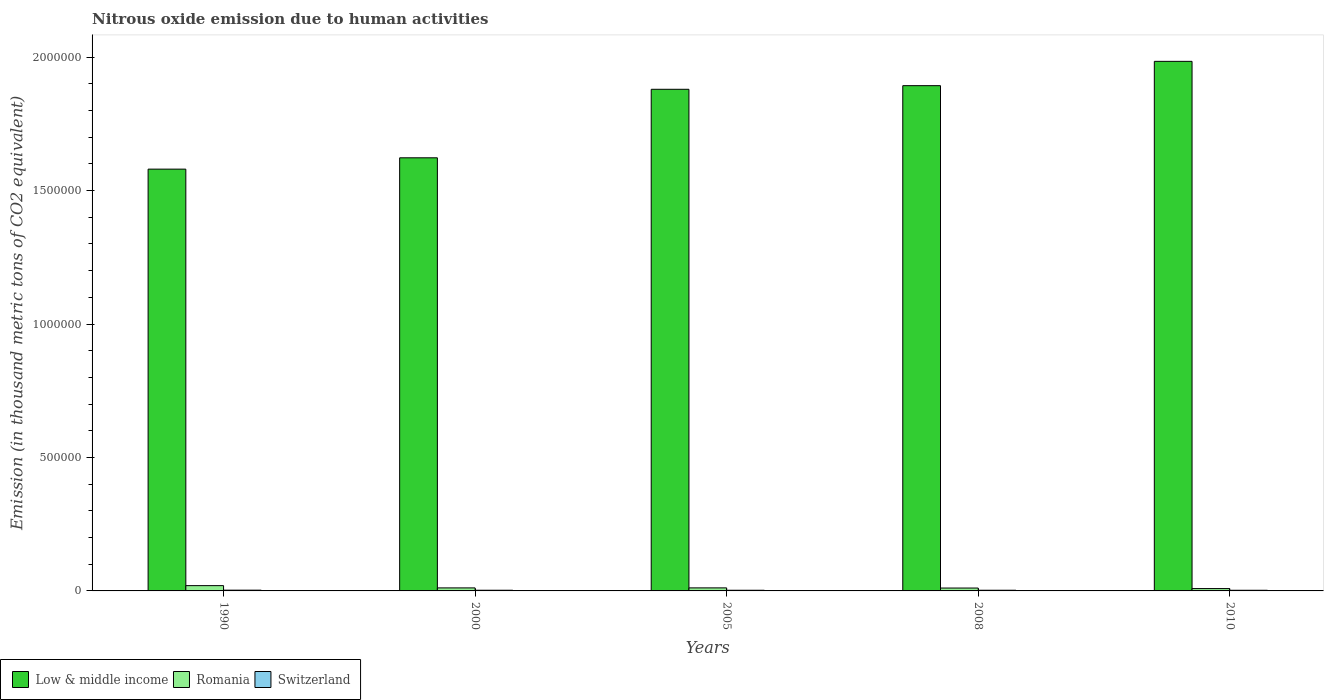How many different coloured bars are there?
Keep it short and to the point. 3. What is the label of the 4th group of bars from the left?
Offer a terse response. 2008. In how many cases, is the number of bars for a given year not equal to the number of legend labels?
Your response must be concise. 0. What is the amount of nitrous oxide emitted in Low & middle income in 2005?
Provide a short and direct response. 1.88e+06. Across all years, what is the maximum amount of nitrous oxide emitted in Romania?
Provide a succinct answer. 1.98e+04. Across all years, what is the minimum amount of nitrous oxide emitted in Switzerland?
Your answer should be compact. 2441.9. What is the total amount of nitrous oxide emitted in Low & middle income in the graph?
Ensure brevity in your answer.  8.96e+06. What is the difference between the amount of nitrous oxide emitted in Low & middle income in 2005 and that in 2010?
Offer a terse response. -1.05e+05. What is the difference between the amount of nitrous oxide emitted in Switzerland in 2000 and the amount of nitrous oxide emitted in Low & middle income in 2010?
Your answer should be compact. -1.98e+06. What is the average amount of nitrous oxide emitted in Switzerland per year?
Provide a short and direct response. 2568.88. In the year 2010, what is the difference between the amount of nitrous oxide emitted in Low & middle income and amount of nitrous oxide emitted in Switzerland?
Give a very brief answer. 1.98e+06. What is the ratio of the amount of nitrous oxide emitted in Low & middle income in 1990 to that in 2005?
Your response must be concise. 0.84. Is the amount of nitrous oxide emitted in Romania in 2000 less than that in 2008?
Make the answer very short. No. What is the difference between the highest and the second highest amount of nitrous oxide emitted in Switzerland?
Your answer should be very brief. 294.5. What is the difference between the highest and the lowest amount of nitrous oxide emitted in Low & middle income?
Keep it short and to the point. 4.04e+05. In how many years, is the amount of nitrous oxide emitted in Low & middle income greater than the average amount of nitrous oxide emitted in Low & middle income taken over all years?
Give a very brief answer. 3. Is the sum of the amount of nitrous oxide emitted in Switzerland in 1990 and 2010 greater than the maximum amount of nitrous oxide emitted in Low & middle income across all years?
Offer a very short reply. No. What does the 2nd bar from the left in 1990 represents?
Provide a succinct answer. Romania. What does the 2nd bar from the right in 2010 represents?
Offer a very short reply. Romania. Is it the case that in every year, the sum of the amount of nitrous oxide emitted in Switzerland and amount of nitrous oxide emitted in Romania is greater than the amount of nitrous oxide emitted in Low & middle income?
Make the answer very short. No. How many bars are there?
Ensure brevity in your answer.  15. Are all the bars in the graph horizontal?
Offer a very short reply. No. How many years are there in the graph?
Your answer should be compact. 5. What is the difference between two consecutive major ticks on the Y-axis?
Offer a terse response. 5.00e+05. Does the graph contain any zero values?
Offer a very short reply. No. Does the graph contain grids?
Offer a very short reply. No. Where does the legend appear in the graph?
Your answer should be compact. Bottom left. How are the legend labels stacked?
Provide a succinct answer. Horizontal. What is the title of the graph?
Your answer should be very brief. Nitrous oxide emission due to human activities. What is the label or title of the X-axis?
Keep it short and to the point. Years. What is the label or title of the Y-axis?
Provide a short and direct response. Emission (in thousand metric tons of CO2 equivalent). What is the Emission (in thousand metric tons of CO2 equivalent) in Low & middle income in 1990?
Provide a succinct answer. 1.58e+06. What is the Emission (in thousand metric tons of CO2 equivalent) of Romania in 1990?
Offer a terse response. 1.98e+04. What is the Emission (in thousand metric tons of CO2 equivalent) of Switzerland in 1990?
Provide a short and direct response. 2846.4. What is the Emission (in thousand metric tons of CO2 equivalent) of Low & middle income in 2000?
Provide a succinct answer. 1.62e+06. What is the Emission (in thousand metric tons of CO2 equivalent) of Romania in 2000?
Your response must be concise. 1.13e+04. What is the Emission (in thousand metric tons of CO2 equivalent) in Switzerland in 2000?
Make the answer very short. 2551.9. What is the Emission (in thousand metric tons of CO2 equivalent) of Low & middle income in 2005?
Your answer should be compact. 1.88e+06. What is the Emission (in thousand metric tons of CO2 equivalent) of Romania in 2005?
Provide a short and direct response. 1.14e+04. What is the Emission (in thousand metric tons of CO2 equivalent) in Switzerland in 2005?
Ensure brevity in your answer.  2463.6. What is the Emission (in thousand metric tons of CO2 equivalent) in Low & middle income in 2008?
Offer a terse response. 1.89e+06. What is the Emission (in thousand metric tons of CO2 equivalent) in Romania in 2008?
Keep it short and to the point. 1.08e+04. What is the Emission (in thousand metric tons of CO2 equivalent) in Switzerland in 2008?
Keep it short and to the point. 2540.6. What is the Emission (in thousand metric tons of CO2 equivalent) in Low & middle income in 2010?
Your response must be concise. 1.98e+06. What is the Emission (in thousand metric tons of CO2 equivalent) in Romania in 2010?
Provide a succinct answer. 8808.3. What is the Emission (in thousand metric tons of CO2 equivalent) of Switzerland in 2010?
Your response must be concise. 2441.9. Across all years, what is the maximum Emission (in thousand metric tons of CO2 equivalent) in Low & middle income?
Your response must be concise. 1.98e+06. Across all years, what is the maximum Emission (in thousand metric tons of CO2 equivalent) of Romania?
Ensure brevity in your answer.  1.98e+04. Across all years, what is the maximum Emission (in thousand metric tons of CO2 equivalent) of Switzerland?
Offer a terse response. 2846.4. Across all years, what is the minimum Emission (in thousand metric tons of CO2 equivalent) of Low & middle income?
Your answer should be very brief. 1.58e+06. Across all years, what is the minimum Emission (in thousand metric tons of CO2 equivalent) of Romania?
Your response must be concise. 8808.3. Across all years, what is the minimum Emission (in thousand metric tons of CO2 equivalent) in Switzerland?
Give a very brief answer. 2441.9. What is the total Emission (in thousand metric tons of CO2 equivalent) in Low & middle income in the graph?
Your answer should be very brief. 8.96e+06. What is the total Emission (in thousand metric tons of CO2 equivalent) in Romania in the graph?
Your response must be concise. 6.21e+04. What is the total Emission (in thousand metric tons of CO2 equivalent) in Switzerland in the graph?
Offer a very short reply. 1.28e+04. What is the difference between the Emission (in thousand metric tons of CO2 equivalent) of Low & middle income in 1990 and that in 2000?
Offer a very short reply. -4.25e+04. What is the difference between the Emission (in thousand metric tons of CO2 equivalent) in Romania in 1990 and that in 2000?
Provide a succinct answer. 8468. What is the difference between the Emission (in thousand metric tons of CO2 equivalent) of Switzerland in 1990 and that in 2000?
Offer a very short reply. 294.5. What is the difference between the Emission (in thousand metric tons of CO2 equivalent) in Low & middle income in 1990 and that in 2005?
Provide a succinct answer. -2.99e+05. What is the difference between the Emission (in thousand metric tons of CO2 equivalent) of Romania in 1990 and that in 2005?
Make the answer very short. 8442.4. What is the difference between the Emission (in thousand metric tons of CO2 equivalent) of Switzerland in 1990 and that in 2005?
Your answer should be compact. 382.8. What is the difference between the Emission (in thousand metric tons of CO2 equivalent) in Low & middle income in 1990 and that in 2008?
Provide a succinct answer. -3.13e+05. What is the difference between the Emission (in thousand metric tons of CO2 equivalent) of Romania in 1990 and that in 2008?
Offer a terse response. 8981.2. What is the difference between the Emission (in thousand metric tons of CO2 equivalent) in Switzerland in 1990 and that in 2008?
Your answer should be very brief. 305.8. What is the difference between the Emission (in thousand metric tons of CO2 equivalent) in Low & middle income in 1990 and that in 2010?
Your answer should be compact. -4.04e+05. What is the difference between the Emission (in thousand metric tons of CO2 equivalent) in Romania in 1990 and that in 2010?
Your response must be concise. 1.10e+04. What is the difference between the Emission (in thousand metric tons of CO2 equivalent) in Switzerland in 1990 and that in 2010?
Keep it short and to the point. 404.5. What is the difference between the Emission (in thousand metric tons of CO2 equivalent) in Low & middle income in 2000 and that in 2005?
Ensure brevity in your answer.  -2.57e+05. What is the difference between the Emission (in thousand metric tons of CO2 equivalent) in Romania in 2000 and that in 2005?
Give a very brief answer. -25.6. What is the difference between the Emission (in thousand metric tons of CO2 equivalent) of Switzerland in 2000 and that in 2005?
Your answer should be compact. 88.3. What is the difference between the Emission (in thousand metric tons of CO2 equivalent) of Low & middle income in 2000 and that in 2008?
Offer a very short reply. -2.70e+05. What is the difference between the Emission (in thousand metric tons of CO2 equivalent) of Romania in 2000 and that in 2008?
Offer a terse response. 513.2. What is the difference between the Emission (in thousand metric tons of CO2 equivalent) of Switzerland in 2000 and that in 2008?
Your answer should be very brief. 11.3. What is the difference between the Emission (in thousand metric tons of CO2 equivalent) in Low & middle income in 2000 and that in 2010?
Your response must be concise. -3.61e+05. What is the difference between the Emission (in thousand metric tons of CO2 equivalent) of Romania in 2000 and that in 2010?
Your answer should be compact. 2527.5. What is the difference between the Emission (in thousand metric tons of CO2 equivalent) of Switzerland in 2000 and that in 2010?
Make the answer very short. 110. What is the difference between the Emission (in thousand metric tons of CO2 equivalent) of Low & middle income in 2005 and that in 2008?
Your response must be concise. -1.36e+04. What is the difference between the Emission (in thousand metric tons of CO2 equivalent) in Romania in 2005 and that in 2008?
Your answer should be compact. 538.8. What is the difference between the Emission (in thousand metric tons of CO2 equivalent) in Switzerland in 2005 and that in 2008?
Give a very brief answer. -77. What is the difference between the Emission (in thousand metric tons of CO2 equivalent) in Low & middle income in 2005 and that in 2010?
Your answer should be compact. -1.05e+05. What is the difference between the Emission (in thousand metric tons of CO2 equivalent) in Romania in 2005 and that in 2010?
Offer a very short reply. 2553.1. What is the difference between the Emission (in thousand metric tons of CO2 equivalent) of Switzerland in 2005 and that in 2010?
Keep it short and to the point. 21.7. What is the difference between the Emission (in thousand metric tons of CO2 equivalent) in Low & middle income in 2008 and that in 2010?
Keep it short and to the point. -9.11e+04. What is the difference between the Emission (in thousand metric tons of CO2 equivalent) in Romania in 2008 and that in 2010?
Your answer should be compact. 2014.3. What is the difference between the Emission (in thousand metric tons of CO2 equivalent) of Switzerland in 2008 and that in 2010?
Offer a very short reply. 98.7. What is the difference between the Emission (in thousand metric tons of CO2 equivalent) in Low & middle income in 1990 and the Emission (in thousand metric tons of CO2 equivalent) in Romania in 2000?
Your response must be concise. 1.57e+06. What is the difference between the Emission (in thousand metric tons of CO2 equivalent) in Low & middle income in 1990 and the Emission (in thousand metric tons of CO2 equivalent) in Switzerland in 2000?
Ensure brevity in your answer.  1.58e+06. What is the difference between the Emission (in thousand metric tons of CO2 equivalent) in Romania in 1990 and the Emission (in thousand metric tons of CO2 equivalent) in Switzerland in 2000?
Make the answer very short. 1.73e+04. What is the difference between the Emission (in thousand metric tons of CO2 equivalent) of Low & middle income in 1990 and the Emission (in thousand metric tons of CO2 equivalent) of Romania in 2005?
Make the answer very short. 1.57e+06. What is the difference between the Emission (in thousand metric tons of CO2 equivalent) in Low & middle income in 1990 and the Emission (in thousand metric tons of CO2 equivalent) in Switzerland in 2005?
Offer a very short reply. 1.58e+06. What is the difference between the Emission (in thousand metric tons of CO2 equivalent) of Romania in 1990 and the Emission (in thousand metric tons of CO2 equivalent) of Switzerland in 2005?
Offer a terse response. 1.73e+04. What is the difference between the Emission (in thousand metric tons of CO2 equivalent) in Low & middle income in 1990 and the Emission (in thousand metric tons of CO2 equivalent) in Romania in 2008?
Your answer should be very brief. 1.57e+06. What is the difference between the Emission (in thousand metric tons of CO2 equivalent) of Low & middle income in 1990 and the Emission (in thousand metric tons of CO2 equivalent) of Switzerland in 2008?
Keep it short and to the point. 1.58e+06. What is the difference between the Emission (in thousand metric tons of CO2 equivalent) of Romania in 1990 and the Emission (in thousand metric tons of CO2 equivalent) of Switzerland in 2008?
Provide a short and direct response. 1.73e+04. What is the difference between the Emission (in thousand metric tons of CO2 equivalent) of Low & middle income in 1990 and the Emission (in thousand metric tons of CO2 equivalent) of Romania in 2010?
Keep it short and to the point. 1.57e+06. What is the difference between the Emission (in thousand metric tons of CO2 equivalent) of Low & middle income in 1990 and the Emission (in thousand metric tons of CO2 equivalent) of Switzerland in 2010?
Provide a short and direct response. 1.58e+06. What is the difference between the Emission (in thousand metric tons of CO2 equivalent) of Romania in 1990 and the Emission (in thousand metric tons of CO2 equivalent) of Switzerland in 2010?
Your response must be concise. 1.74e+04. What is the difference between the Emission (in thousand metric tons of CO2 equivalent) of Low & middle income in 2000 and the Emission (in thousand metric tons of CO2 equivalent) of Romania in 2005?
Make the answer very short. 1.61e+06. What is the difference between the Emission (in thousand metric tons of CO2 equivalent) of Low & middle income in 2000 and the Emission (in thousand metric tons of CO2 equivalent) of Switzerland in 2005?
Ensure brevity in your answer.  1.62e+06. What is the difference between the Emission (in thousand metric tons of CO2 equivalent) of Romania in 2000 and the Emission (in thousand metric tons of CO2 equivalent) of Switzerland in 2005?
Offer a terse response. 8872.2. What is the difference between the Emission (in thousand metric tons of CO2 equivalent) in Low & middle income in 2000 and the Emission (in thousand metric tons of CO2 equivalent) in Romania in 2008?
Offer a very short reply. 1.61e+06. What is the difference between the Emission (in thousand metric tons of CO2 equivalent) in Low & middle income in 2000 and the Emission (in thousand metric tons of CO2 equivalent) in Switzerland in 2008?
Your answer should be very brief. 1.62e+06. What is the difference between the Emission (in thousand metric tons of CO2 equivalent) in Romania in 2000 and the Emission (in thousand metric tons of CO2 equivalent) in Switzerland in 2008?
Provide a succinct answer. 8795.2. What is the difference between the Emission (in thousand metric tons of CO2 equivalent) of Low & middle income in 2000 and the Emission (in thousand metric tons of CO2 equivalent) of Romania in 2010?
Offer a terse response. 1.61e+06. What is the difference between the Emission (in thousand metric tons of CO2 equivalent) in Low & middle income in 2000 and the Emission (in thousand metric tons of CO2 equivalent) in Switzerland in 2010?
Your answer should be very brief. 1.62e+06. What is the difference between the Emission (in thousand metric tons of CO2 equivalent) of Romania in 2000 and the Emission (in thousand metric tons of CO2 equivalent) of Switzerland in 2010?
Keep it short and to the point. 8893.9. What is the difference between the Emission (in thousand metric tons of CO2 equivalent) in Low & middle income in 2005 and the Emission (in thousand metric tons of CO2 equivalent) in Romania in 2008?
Provide a succinct answer. 1.87e+06. What is the difference between the Emission (in thousand metric tons of CO2 equivalent) in Low & middle income in 2005 and the Emission (in thousand metric tons of CO2 equivalent) in Switzerland in 2008?
Make the answer very short. 1.88e+06. What is the difference between the Emission (in thousand metric tons of CO2 equivalent) of Romania in 2005 and the Emission (in thousand metric tons of CO2 equivalent) of Switzerland in 2008?
Offer a very short reply. 8820.8. What is the difference between the Emission (in thousand metric tons of CO2 equivalent) of Low & middle income in 2005 and the Emission (in thousand metric tons of CO2 equivalent) of Romania in 2010?
Provide a succinct answer. 1.87e+06. What is the difference between the Emission (in thousand metric tons of CO2 equivalent) of Low & middle income in 2005 and the Emission (in thousand metric tons of CO2 equivalent) of Switzerland in 2010?
Offer a terse response. 1.88e+06. What is the difference between the Emission (in thousand metric tons of CO2 equivalent) in Romania in 2005 and the Emission (in thousand metric tons of CO2 equivalent) in Switzerland in 2010?
Provide a succinct answer. 8919.5. What is the difference between the Emission (in thousand metric tons of CO2 equivalent) in Low & middle income in 2008 and the Emission (in thousand metric tons of CO2 equivalent) in Romania in 2010?
Provide a succinct answer. 1.88e+06. What is the difference between the Emission (in thousand metric tons of CO2 equivalent) of Low & middle income in 2008 and the Emission (in thousand metric tons of CO2 equivalent) of Switzerland in 2010?
Offer a very short reply. 1.89e+06. What is the difference between the Emission (in thousand metric tons of CO2 equivalent) in Romania in 2008 and the Emission (in thousand metric tons of CO2 equivalent) in Switzerland in 2010?
Provide a short and direct response. 8380.7. What is the average Emission (in thousand metric tons of CO2 equivalent) in Low & middle income per year?
Your answer should be very brief. 1.79e+06. What is the average Emission (in thousand metric tons of CO2 equivalent) in Romania per year?
Ensure brevity in your answer.  1.24e+04. What is the average Emission (in thousand metric tons of CO2 equivalent) of Switzerland per year?
Your answer should be very brief. 2568.88. In the year 1990, what is the difference between the Emission (in thousand metric tons of CO2 equivalent) in Low & middle income and Emission (in thousand metric tons of CO2 equivalent) in Romania?
Your answer should be very brief. 1.56e+06. In the year 1990, what is the difference between the Emission (in thousand metric tons of CO2 equivalent) in Low & middle income and Emission (in thousand metric tons of CO2 equivalent) in Switzerland?
Offer a terse response. 1.58e+06. In the year 1990, what is the difference between the Emission (in thousand metric tons of CO2 equivalent) of Romania and Emission (in thousand metric tons of CO2 equivalent) of Switzerland?
Your answer should be very brief. 1.70e+04. In the year 2000, what is the difference between the Emission (in thousand metric tons of CO2 equivalent) in Low & middle income and Emission (in thousand metric tons of CO2 equivalent) in Romania?
Offer a terse response. 1.61e+06. In the year 2000, what is the difference between the Emission (in thousand metric tons of CO2 equivalent) in Low & middle income and Emission (in thousand metric tons of CO2 equivalent) in Switzerland?
Provide a succinct answer. 1.62e+06. In the year 2000, what is the difference between the Emission (in thousand metric tons of CO2 equivalent) in Romania and Emission (in thousand metric tons of CO2 equivalent) in Switzerland?
Your answer should be very brief. 8783.9. In the year 2005, what is the difference between the Emission (in thousand metric tons of CO2 equivalent) in Low & middle income and Emission (in thousand metric tons of CO2 equivalent) in Romania?
Provide a short and direct response. 1.87e+06. In the year 2005, what is the difference between the Emission (in thousand metric tons of CO2 equivalent) in Low & middle income and Emission (in thousand metric tons of CO2 equivalent) in Switzerland?
Keep it short and to the point. 1.88e+06. In the year 2005, what is the difference between the Emission (in thousand metric tons of CO2 equivalent) in Romania and Emission (in thousand metric tons of CO2 equivalent) in Switzerland?
Your response must be concise. 8897.8. In the year 2008, what is the difference between the Emission (in thousand metric tons of CO2 equivalent) of Low & middle income and Emission (in thousand metric tons of CO2 equivalent) of Romania?
Offer a very short reply. 1.88e+06. In the year 2008, what is the difference between the Emission (in thousand metric tons of CO2 equivalent) of Low & middle income and Emission (in thousand metric tons of CO2 equivalent) of Switzerland?
Your answer should be compact. 1.89e+06. In the year 2008, what is the difference between the Emission (in thousand metric tons of CO2 equivalent) of Romania and Emission (in thousand metric tons of CO2 equivalent) of Switzerland?
Keep it short and to the point. 8282. In the year 2010, what is the difference between the Emission (in thousand metric tons of CO2 equivalent) in Low & middle income and Emission (in thousand metric tons of CO2 equivalent) in Romania?
Make the answer very short. 1.98e+06. In the year 2010, what is the difference between the Emission (in thousand metric tons of CO2 equivalent) of Low & middle income and Emission (in thousand metric tons of CO2 equivalent) of Switzerland?
Provide a short and direct response. 1.98e+06. In the year 2010, what is the difference between the Emission (in thousand metric tons of CO2 equivalent) in Romania and Emission (in thousand metric tons of CO2 equivalent) in Switzerland?
Provide a short and direct response. 6366.4. What is the ratio of the Emission (in thousand metric tons of CO2 equivalent) of Low & middle income in 1990 to that in 2000?
Keep it short and to the point. 0.97. What is the ratio of the Emission (in thousand metric tons of CO2 equivalent) in Romania in 1990 to that in 2000?
Your answer should be very brief. 1.75. What is the ratio of the Emission (in thousand metric tons of CO2 equivalent) of Switzerland in 1990 to that in 2000?
Offer a terse response. 1.12. What is the ratio of the Emission (in thousand metric tons of CO2 equivalent) in Low & middle income in 1990 to that in 2005?
Provide a succinct answer. 0.84. What is the ratio of the Emission (in thousand metric tons of CO2 equivalent) in Romania in 1990 to that in 2005?
Offer a terse response. 1.74. What is the ratio of the Emission (in thousand metric tons of CO2 equivalent) in Switzerland in 1990 to that in 2005?
Your answer should be compact. 1.16. What is the ratio of the Emission (in thousand metric tons of CO2 equivalent) of Low & middle income in 1990 to that in 2008?
Your response must be concise. 0.83. What is the ratio of the Emission (in thousand metric tons of CO2 equivalent) of Romania in 1990 to that in 2008?
Provide a short and direct response. 1.83. What is the ratio of the Emission (in thousand metric tons of CO2 equivalent) of Switzerland in 1990 to that in 2008?
Your response must be concise. 1.12. What is the ratio of the Emission (in thousand metric tons of CO2 equivalent) of Low & middle income in 1990 to that in 2010?
Keep it short and to the point. 0.8. What is the ratio of the Emission (in thousand metric tons of CO2 equivalent) of Romania in 1990 to that in 2010?
Your answer should be compact. 2.25. What is the ratio of the Emission (in thousand metric tons of CO2 equivalent) of Switzerland in 1990 to that in 2010?
Provide a succinct answer. 1.17. What is the ratio of the Emission (in thousand metric tons of CO2 equivalent) in Low & middle income in 2000 to that in 2005?
Ensure brevity in your answer.  0.86. What is the ratio of the Emission (in thousand metric tons of CO2 equivalent) of Romania in 2000 to that in 2005?
Make the answer very short. 1. What is the ratio of the Emission (in thousand metric tons of CO2 equivalent) of Switzerland in 2000 to that in 2005?
Your answer should be compact. 1.04. What is the ratio of the Emission (in thousand metric tons of CO2 equivalent) in Low & middle income in 2000 to that in 2008?
Your response must be concise. 0.86. What is the ratio of the Emission (in thousand metric tons of CO2 equivalent) of Romania in 2000 to that in 2008?
Make the answer very short. 1.05. What is the ratio of the Emission (in thousand metric tons of CO2 equivalent) in Low & middle income in 2000 to that in 2010?
Your answer should be very brief. 0.82. What is the ratio of the Emission (in thousand metric tons of CO2 equivalent) of Romania in 2000 to that in 2010?
Offer a very short reply. 1.29. What is the ratio of the Emission (in thousand metric tons of CO2 equivalent) of Switzerland in 2000 to that in 2010?
Give a very brief answer. 1.04. What is the ratio of the Emission (in thousand metric tons of CO2 equivalent) in Romania in 2005 to that in 2008?
Your response must be concise. 1.05. What is the ratio of the Emission (in thousand metric tons of CO2 equivalent) in Switzerland in 2005 to that in 2008?
Provide a succinct answer. 0.97. What is the ratio of the Emission (in thousand metric tons of CO2 equivalent) in Low & middle income in 2005 to that in 2010?
Your response must be concise. 0.95. What is the ratio of the Emission (in thousand metric tons of CO2 equivalent) in Romania in 2005 to that in 2010?
Give a very brief answer. 1.29. What is the ratio of the Emission (in thousand metric tons of CO2 equivalent) of Switzerland in 2005 to that in 2010?
Offer a very short reply. 1.01. What is the ratio of the Emission (in thousand metric tons of CO2 equivalent) in Low & middle income in 2008 to that in 2010?
Keep it short and to the point. 0.95. What is the ratio of the Emission (in thousand metric tons of CO2 equivalent) in Romania in 2008 to that in 2010?
Offer a terse response. 1.23. What is the ratio of the Emission (in thousand metric tons of CO2 equivalent) in Switzerland in 2008 to that in 2010?
Give a very brief answer. 1.04. What is the difference between the highest and the second highest Emission (in thousand metric tons of CO2 equivalent) of Low & middle income?
Keep it short and to the point. 9.11e+04. What is the difference between the highest and the second highest Emission (in thousand metric tons of CO2 equivalent) of Romania?
Provide a succinct answer. 8442.4. What is the difference between the highest and the second highest Emission (in thousand metric tons of CO2 equivalent) of Switzerland?
Provide a short and direct response. 294.5. What is the difference between the highest and the lowest Emission (in thousand metric tons of CO2 equivalent) of Low & middle income?
Offer a very short reply. 4.04e+05. What is the difference between the highest and the lowest Emission (in thousand metric tons of CO2 equivalent) in Romania?
Your answer should be compact. 1.10e+04. What is the difference between the highest and the lowest Emission (in thousand metric tons of CO2 equivalent) in Switzerland?
Keep it short and to the point. 404.5. 